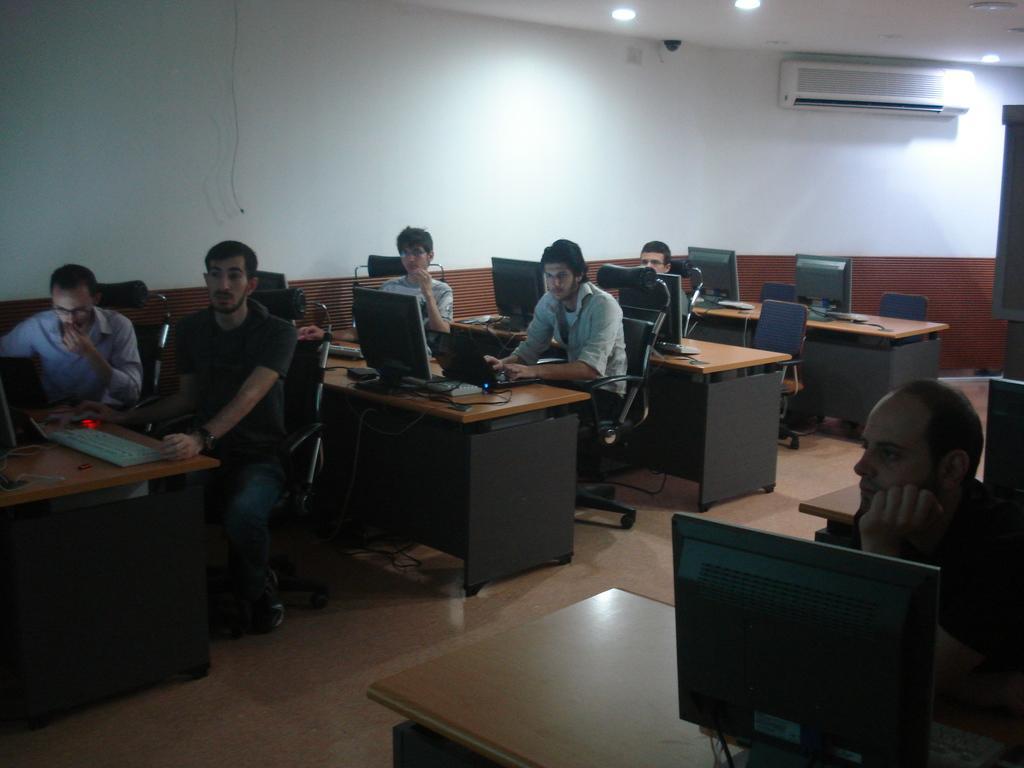How would you summarize this image in a sentence or two? There is a room which includes ceiling light, camera, Air Conditioner and a hanging wire and many number of tables and chairs and there are group of people, all of them are sitting on chairs. On the left side there is a person sitting on chair and working on computer and behind to this person the another person is sitting on chair and working on Laptop and on the right side there is a person sitting and gazing at something. 